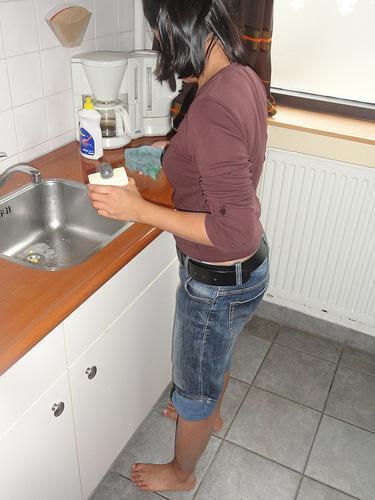How many people are there?
Give a very brief answer. 1. 